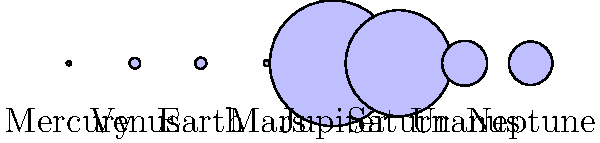In the graphic above, planets are represented by circles scaled according to their relative sizes. Which planet appears to be approximately twice the diameter of Earth? To answer this question, we need to follow these steps:

1. Identify Earth in the diagram: Earth is the third planet from the left.

2. Visually compare Earth's size to the other planets:
   - Mercury and Mars are clearly smaller than Earth.
   - Venus appears to be about the same size as Earth.
   - Jupiter and Saturn are much larger than Earth.
   - Uranus and Neptune are larger than Earth but smaller than Jupiter and Saturn.

3. Estimate which planet has approximately twice the diameter of Earth:
   - Uranus and Neptune appear to be the closest in size to this criterion.
   - Comparing the two, Neptune seems slightly smaller than Uranus.

4. Verify with actual data:
   - Earth's diameter: 12,756 km
   - Uranus' diameter: 51,118 km
   - Neptune's diameter: 49,528 km

5. Calculate the ratio:
   - Uranus to Earth ratio: $\frac{51,118}{12,756} \approx 4.01$
   - Neptune to Earth ratio: $\frac{49,528}{12,756} \approx 3.88$

6. Determine which is closer to 2:
   - Both are closer to 4 times Earth's diameter, but Neptune is slightly closer to 2 times.

Despite the visual representation suggesting Uranus or Neptune, neither is exactly twice Earth's diameter. However, in the context of relative sizes in our solar system, Neptune is the closest to being twice Earth's diameter.
Answer: Neptune 